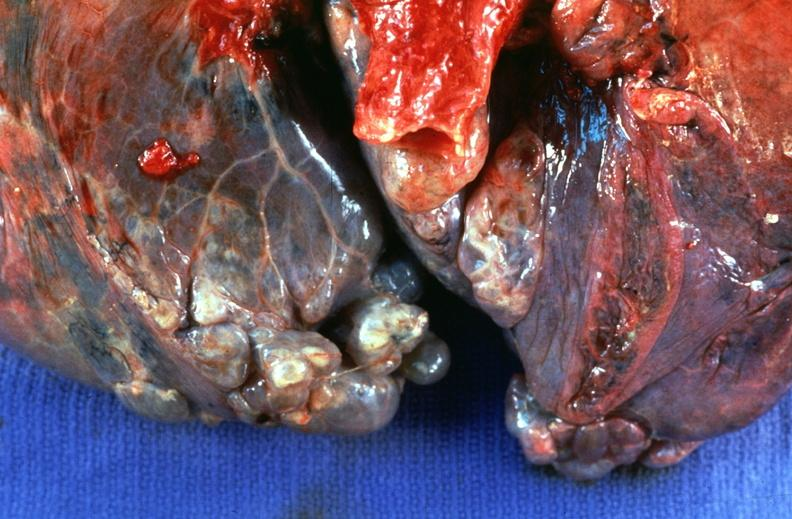s respiratory present?
Answer the question using a single word or phrase. Yes 